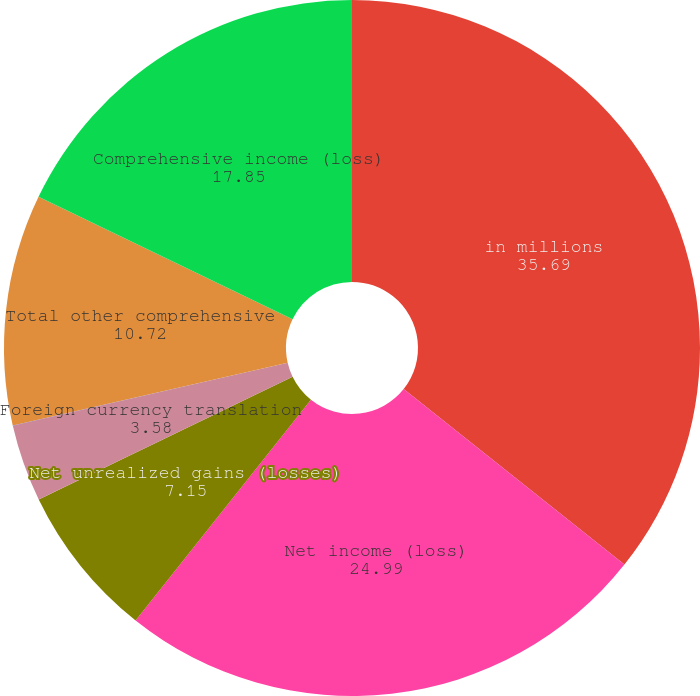Convert chart to OTSL. <chart><loc_0><loc_0><loc_500><loc_500><pie_chart><fcel>in millions<fcel>Net income (loss)<fcel>Net unrealized gains (losses)<fcel>Foreign currency translation<fcel>Net pension and postretirement<fcel>Total other comprehensive<fcel>Comprehensive income (loss)<nl><fcel>35.69%<fcel>24.99%<fcel>7.15%<fcel>3.58%<fcel>0.02%<fcel>10.72%<fcel>17.85%<nl></chart> 